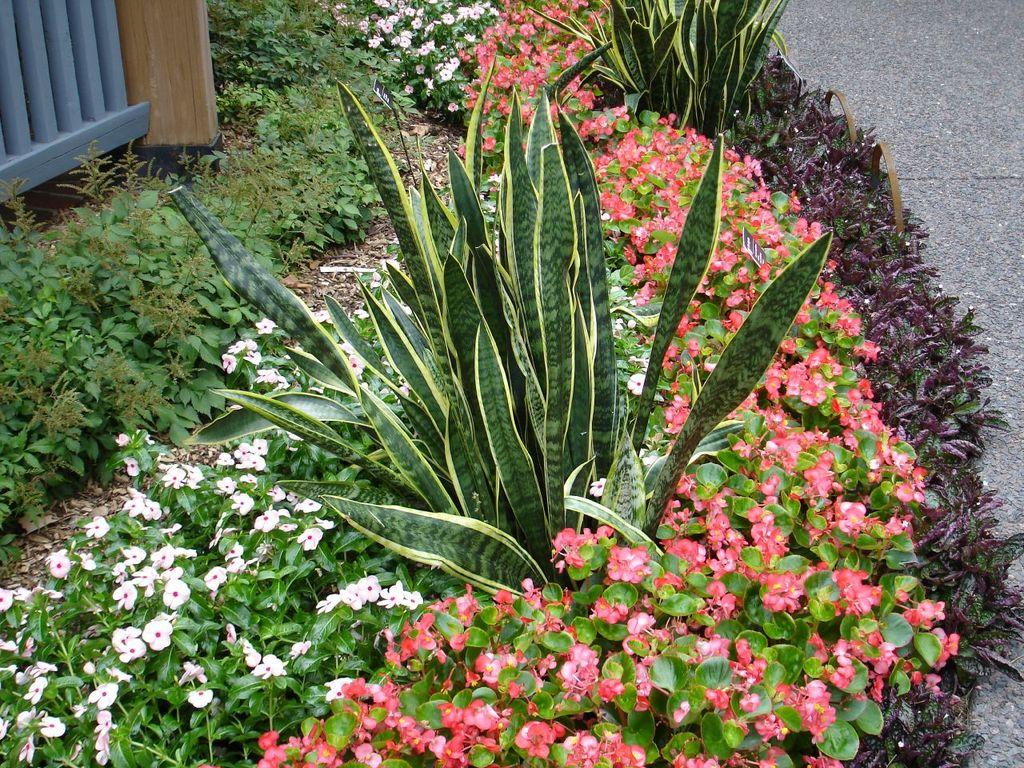What types of vegetation are in the center of the image? There are bushes, flowers, and small plants in the center of the image. What can be seen on the right side of the image? There is a road on the right side of the image. What type of bell can be seen hanging from the bushes in the image? There is no bell present in the image; it features bushes, flowers, and small plants in the center, and a road on the right side. 